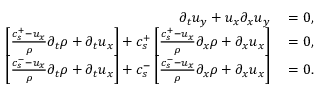<formula> <loc_0><loc_0><loc_500><loc_500>\begin{array} { r l } { \partial _ { t } u _ { y } + u _ { x } \partial _ { x } u _ { y } } & = 0 , } \\ { \left [ \frac { c _ { s } ^ { + } - u _ { x } } { \rho } \partial _ { t } \rho + \partial _ { t } u _ { x } \right ] + c _ { s } ^ { + } \left [ \frac { c _ { s } ^ { + } - u _ { x } } { \rho } \partial _ { x } \rho + \partial _ { x } u _ { x } \right ] } & = 0 , } \\ { \left [ \frac { c _ { s } ^ { - } - u _ { x } } { \rho } \partial _ { t } \rho + \partial _ { t } u _ { x } \right ] + c _ { s } ^ { - } \left [ \frac { c _ { s } ^ { - } - u _ { x } } { \rho } \partial _ { x } \rho + \partial _ { x } u _ { x } \right ] } & = 0 . } \end{array}</formula> 